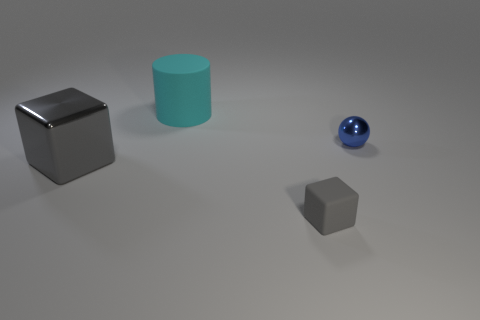Add 1 cylinders. How many objects exist? 5 Subtract all balls. How many objects are left? 3 Add 1 blue balls. How many blue balls are left? 2 Add 2 small blue objects. How many small blue objects exist? 3 Subtract 0 red blocks. How many objects are left? 4 Subtract all big cyan things. Subtract all small gray objects. How many objects are left? 2 